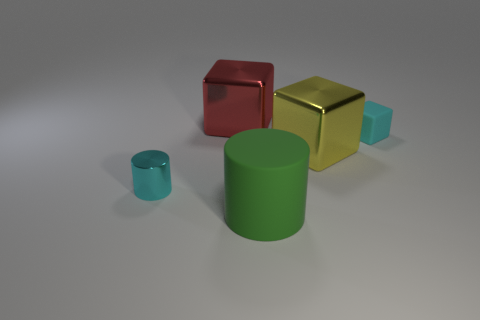Subtract all matte blocks. How many blocks are left? 2 Add 4 tiny cyan matte objects. How many objects exist? 9 Subtract all yellow blocks. How many blocks are left? 2 Add 4 tiny cyan matte blocks. How many tiny cyan matte blocks are left? 5 Add 1 large cylinders. How many large cylinders exist? 2 Subtract 0 purple cylinders. How many objects are left? 5 Subtract all cubes. How many objects are left? 2 Subtract all purple cylinders. Subtract all gray cubes. How many cylinders are left? 2 Subtract all small cyan matte objects. Subtract all big cubes. How many objects are left? 2 